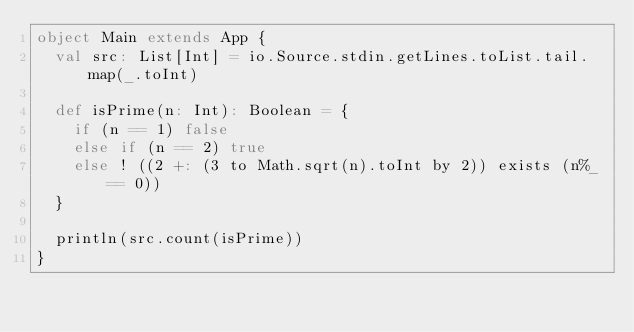<code> <loc_0><loc_0><loc_500><loc_500><_Scala_>object Main extends App {
  val src: List[Int] = io.Source.stdin.getLines.toList.tail.map(_.toInt)

  def isPrime(n: Int): Boolean = {
    if (n == 1) false
    else if (n == 2) true
    else ! ((2 +: (3 to Math.sqrt(n).toInt by 2)) exists (n%_ == 0))
  }

  println(src.count(isPrime))
}</code> 